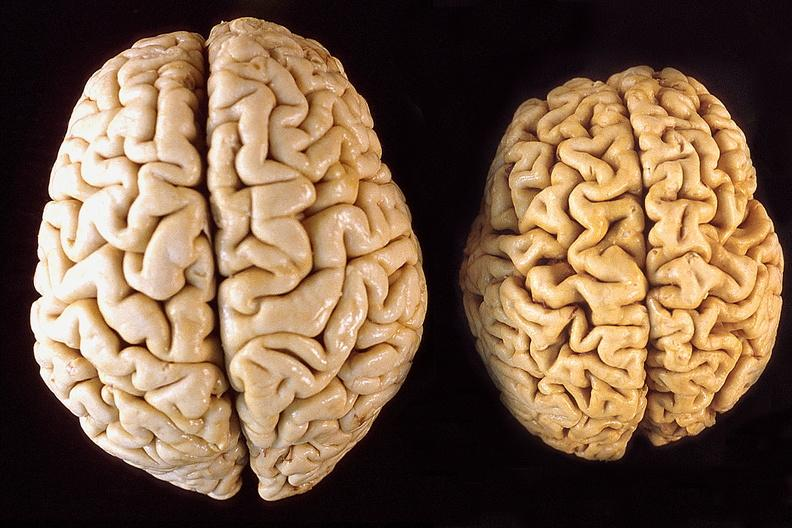s nervous present?
Answer the question using a single word or phrase. Yes 